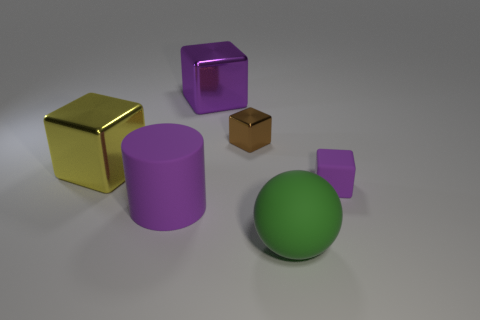Do the large cylinder and the matte cube have the same color?
Ensure brevity in your answer.  Yes. Does the small cube that is in front of the tiny brown shiny cube have the same material as the small brown object?
Your answer should be compact. No. What is the shape of the yellow object?
Ensure brevity in your answer.  Cube. Is the number of purple things in front of the tiny purple rubber block greater than the number of small rubber cylinders?
Make the answer very short. Yes. Are there any other things that are the same shape as the big green rubber object?
Make the answer very short. No. There is another small thing that is the same shape as the brown metal thing; what is its color?
Offer a terse response. Purple. What shape is the tiny object that is left of the large green rubber thing?
Offer a terse response. Cube. There is a purple rubber cube; are there any green rubber things behind it?
Your answer should be very brief. No. There is a large sphere that is the same material as the tiny purple object; what color is it?
Your answer should be compact. Green. Do the shiny object behind the brown shiny cube and the big matte cylinder that is left of the purple metal block have the same color?
Offer a very short reply. Yes. 